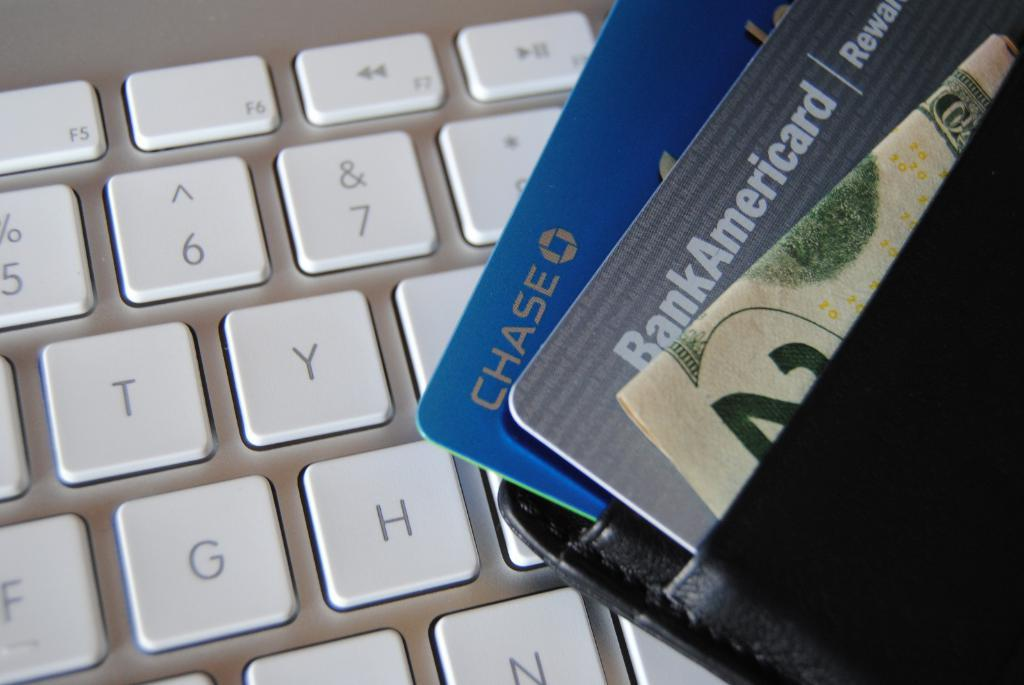<image>
Present a compact description of the photo's key features. A blue chase credit card is in the wallet 